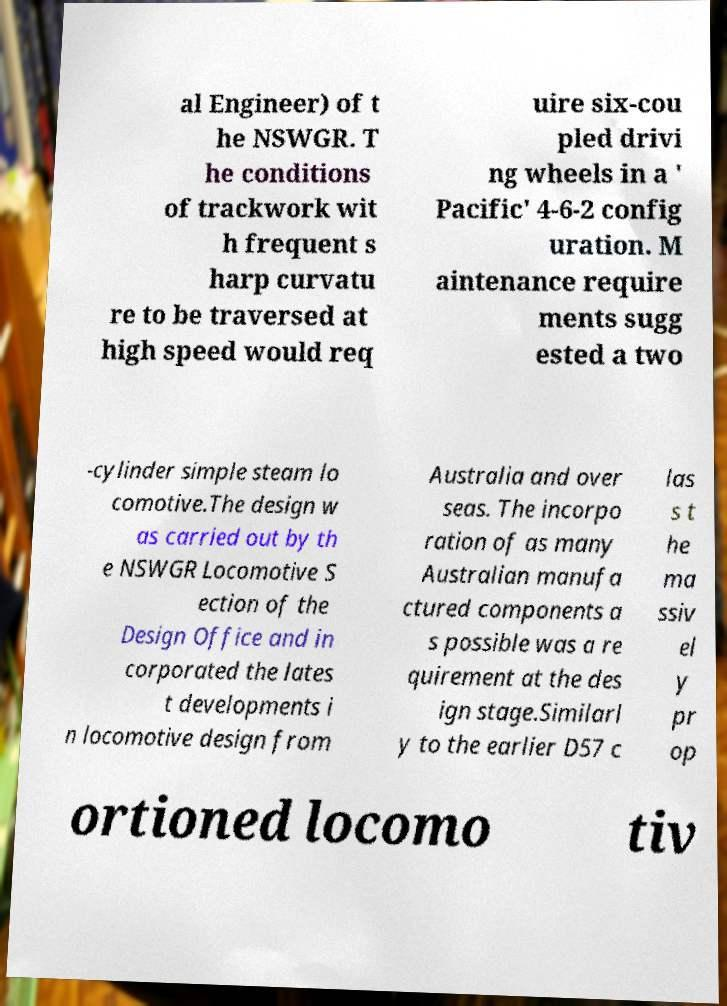Please read and relay the text visible in this image. What does it say? al Engineer) of t he NSWGR. T he conditions of trackwork wit h frequent s harp curvatu re to be traversed at high speed would req uire six-cou pled drivi ng wheels in a ' Pacific' 4-6-2 config uration. M aintenance require ments sugg ested a two -cylinder simple steam lo comotive.The design w as carried out by th e NSWGR Locomotive S ection of the Design Office and in corporated the lates t developments i n locomotive design from Australia and over seas. The incorpo ration of as many Australian manufa ctured components a s possible was a re quirement at the des ign stage.Similarl y to the earlier D57 c las s t he ma ssiv el y pr op ortioned locomo tiv 